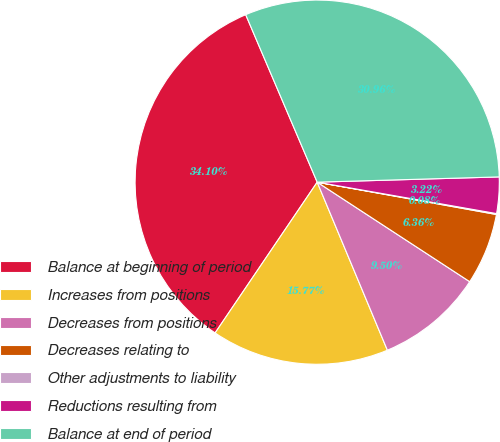Convert chart. <chart><loc_0><loc_0><loc_500><loc_500><pie_chart><fcel>Balance at beginning of period<fcel>Increases from positions<fcel>Decreases from positions<fcel>Decreases relating to<fcel>Other adjustments to liability<fcel>Reductions resulting from<fcel>Balance at end of period<nl><fcel>34.1%<fcel>15.77%<fcel>9.5%<fcel>6.36%<fcel>0.08%<fcel>3.22%<fcel>30.96%<nl></chart> 